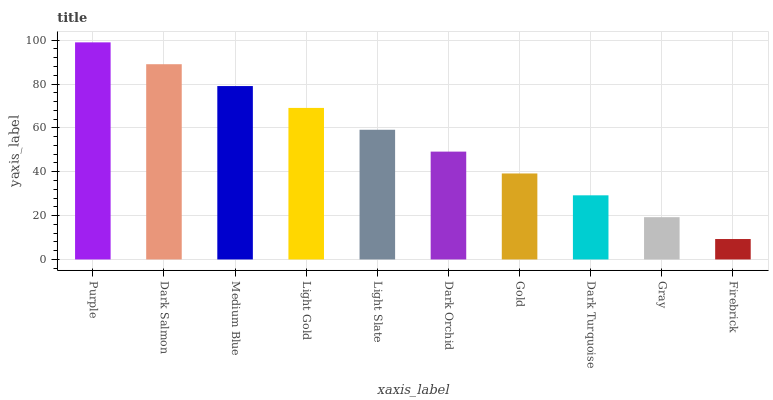Is Dark Salmon the minimum?
Answer yes or no. No. Is Dark Salmon the maximum?
Answer yes or no. No. Is Purple greater than Dark Salmon?
Answer yes or no. Yes. Is Dark Salmon less than Purple?
Answer yes or no. Yes. Is Dark Salmon greater than Purple?
Answer yes or no. No. Is Purple less than Dark Salmon?
Answer yes or no. No. Is Light Slate the high median?
Answer yes or no. Yes. Is Dark Orchid the low median?
Answer yes or no. Yes. Is Dark Orchid the high median?
Answer yes or no. No. Is Purple the low median?
Answer yes or no. No. 